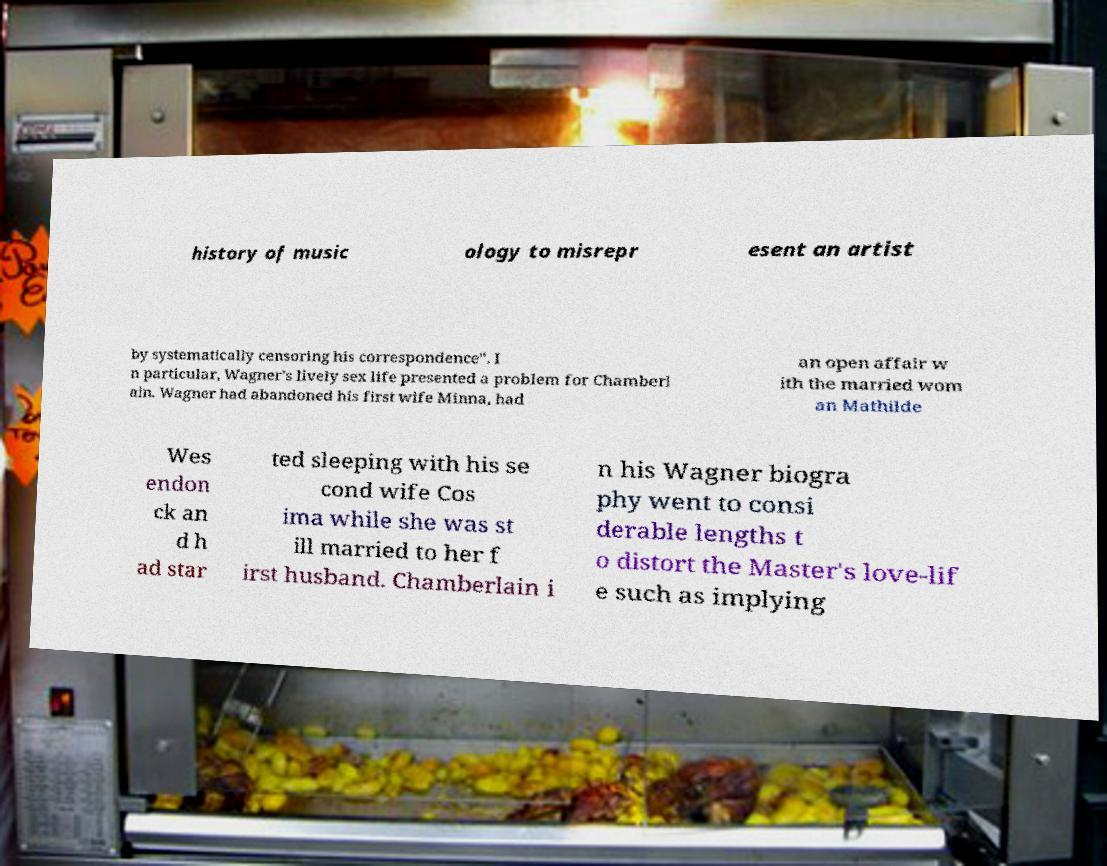For documentation purposes, I need the text within this image transcribed. Could you provide that? history of music ology to misrepr esent an artist by systematically censoring his correspondence". I n particular, Wagner's lively sex life presented a problem for Chamberl ain. Wagner had abandoned his first wife Minna, had an open affair w ith the married wom an Mathilde Wes endon ck an d h ad star ted sleeping with his se cond wife Cos ima while she was st ill married to her f irst husband. Chamberlain i n his Wagner biogra phy went to consi derable lengths t o distort the Master's love-lif e such as implying 